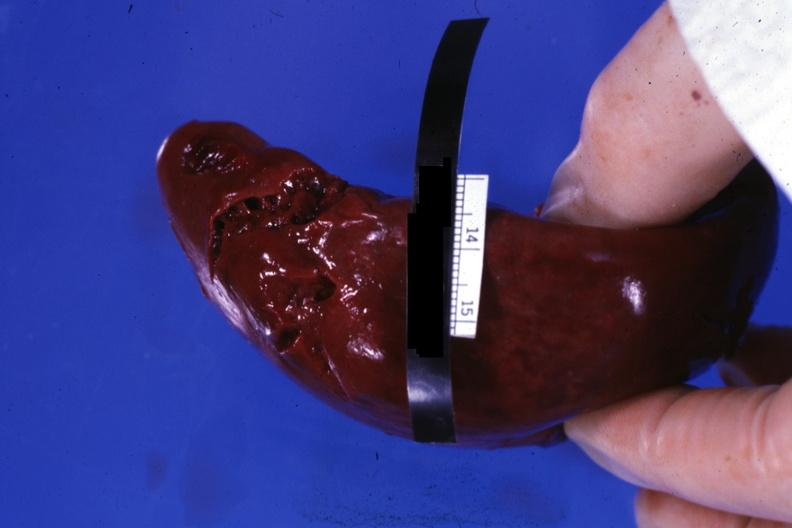s sacrococcygeal teratoma present?
Answer the question using a single word or phrase. No 